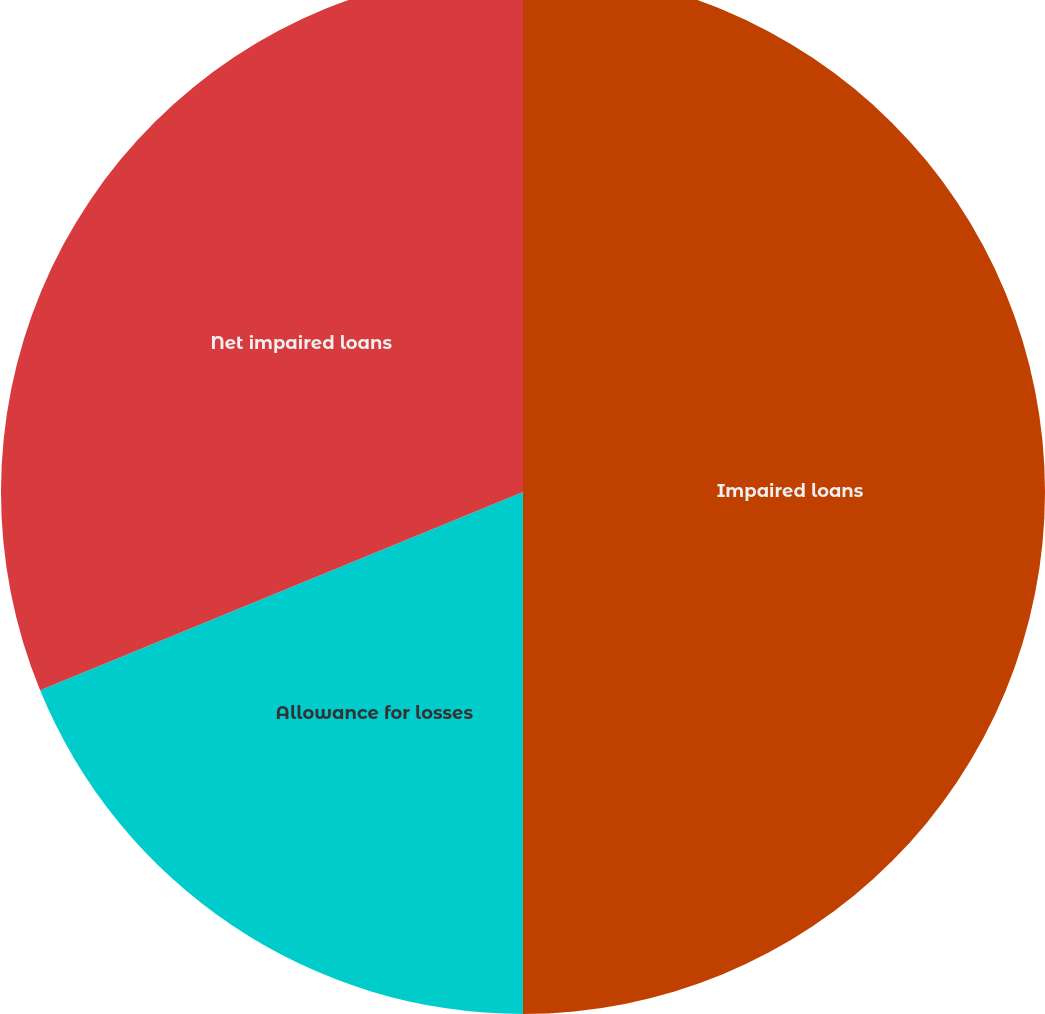Convert chart to OTSL. <chart><loc_0><loc_0><loc_500><loc_500><pie_chart><fcel>Impaired loans<fcel>Allowance for losses<fcel>Net impaired loans<nl><fcel>50.0%<fcel>18.8%<fcel>31.2%<nl></chart> 